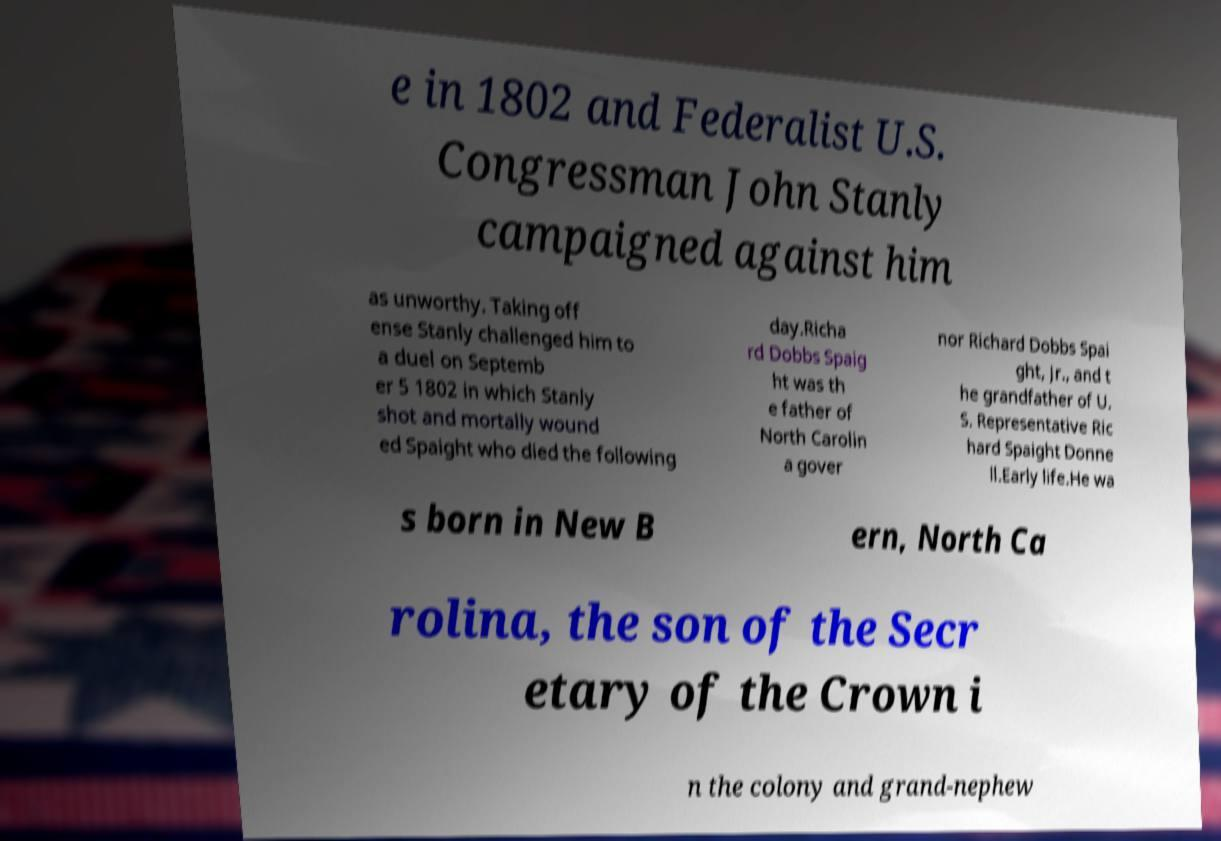There's text embedded in this image that I need extracted. Can you transcribe it verbatim? e in 1802 and Federalist U.S. Congressman John Stanly campaigned against him as unworthy. Taking off ense Stanly challenged him to a duel on Septemb er 5 1802 in which Stanly shot and mortally wound ed Spaight who died the following day.Richa rd Dobbs Spaig ht was th e father of North Carolin a gover nor Richard Dobbs Spai ght, Jr., and t he grandfather of U. S. Representative Ric hard Spaight Donne ll.Early life.He wa s born in New B ern, North Ca rolina, the son of the Secr etary of the Crown i n the colony and grand-nephew 